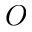Convert formula to latex. <formula><loc_0><loc_0><loc_500><loc_500>O</formula> 